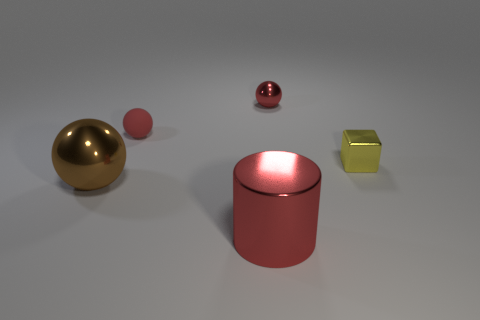What material do these objects seem to be made from? The objects in the image appear to be rendered with materials that mimic the reflective qualities of metals, showcasing shiny surfaces and reflective highlights. 